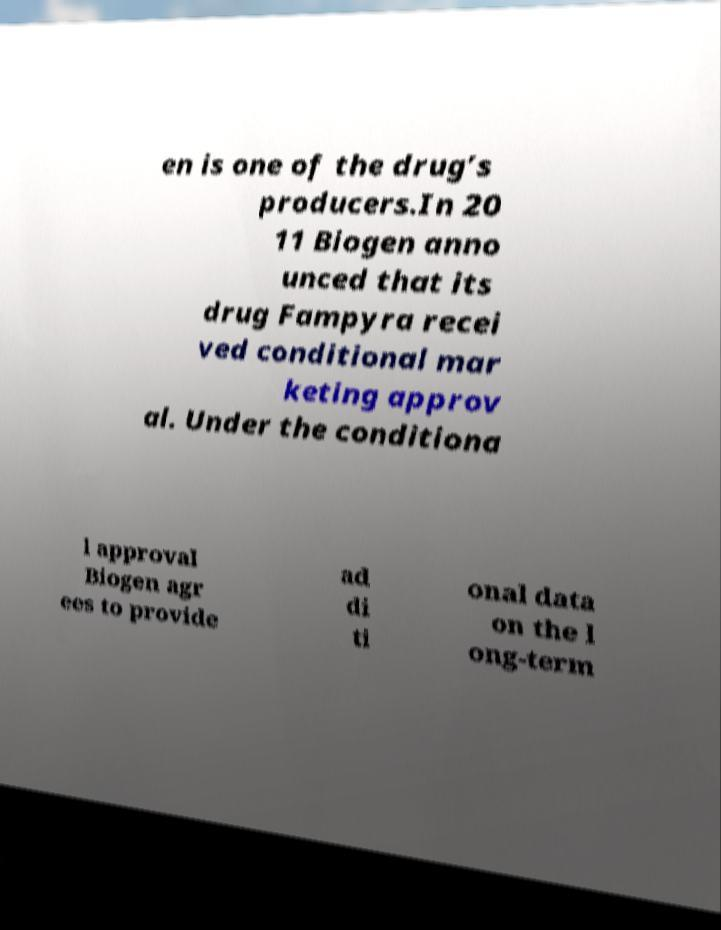Please read and relay the text visible in this image. What does it say? en is one of the drug’s producers.In 20 11 Biogen anno unced that its drug Fampyra recei ved conditional mar keting approv al. Under the conditiona l approval Biogen agr ees to provide ad di ti onal data on the l ong-term 